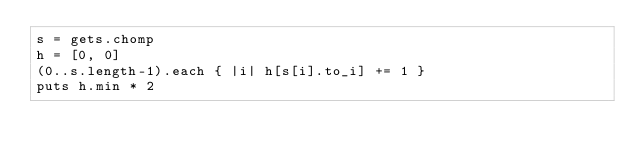Convert code to text. <code><loc_0><loc_0><loc_500><loc_500><_Ruby_>s = gets.chomp
h = [0, 0]
(0..s.length-1).each { |i| h[s[i].to_i] += 1 }
puts h.min * 2</code> 